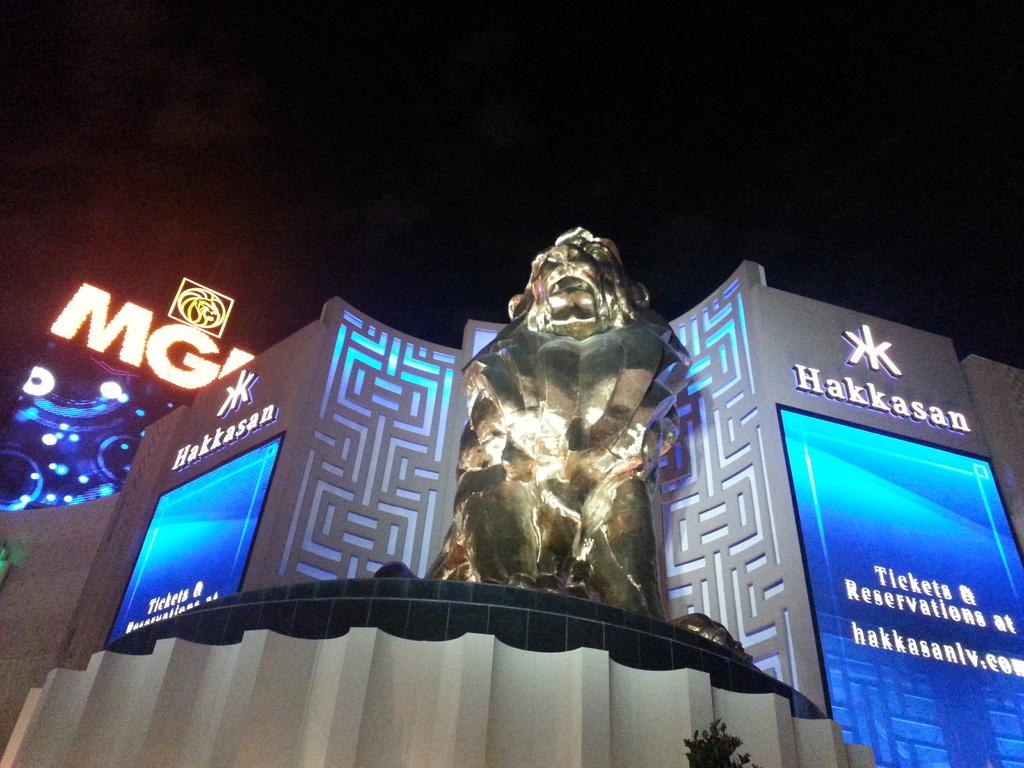<image>
Describe the image concisely. The Hakkasan advertises the website where you can buy tickets and make reservations. 